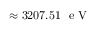<formula> <loc_0><loc_0><loc_500><loc_500>\approx 3 2 0 7 . 5 1 e V</formula> 